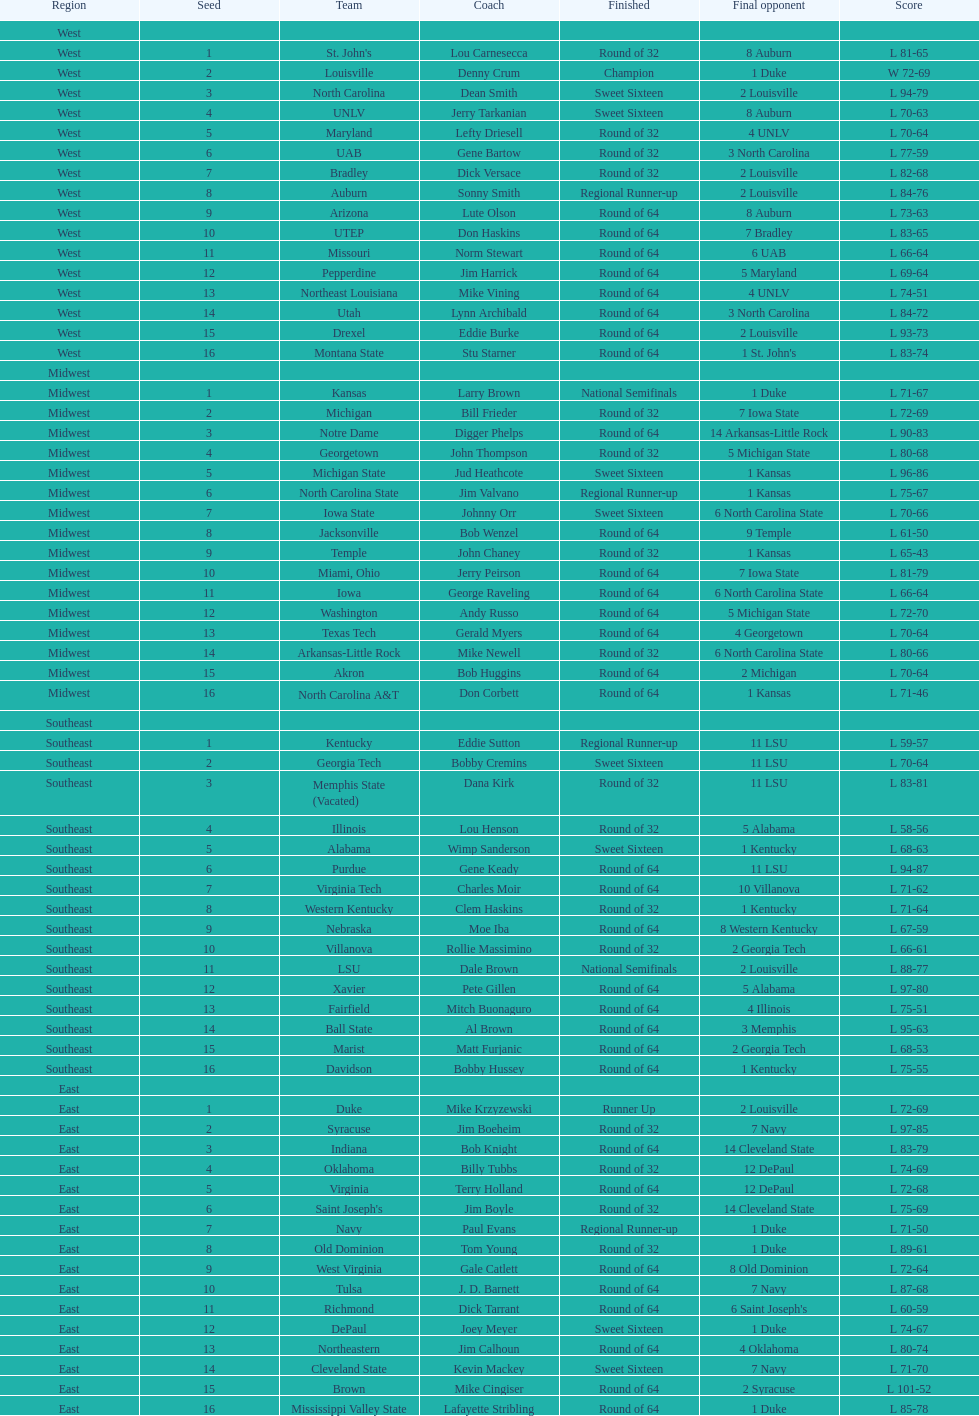What is the overall count of teams that played? 64. 